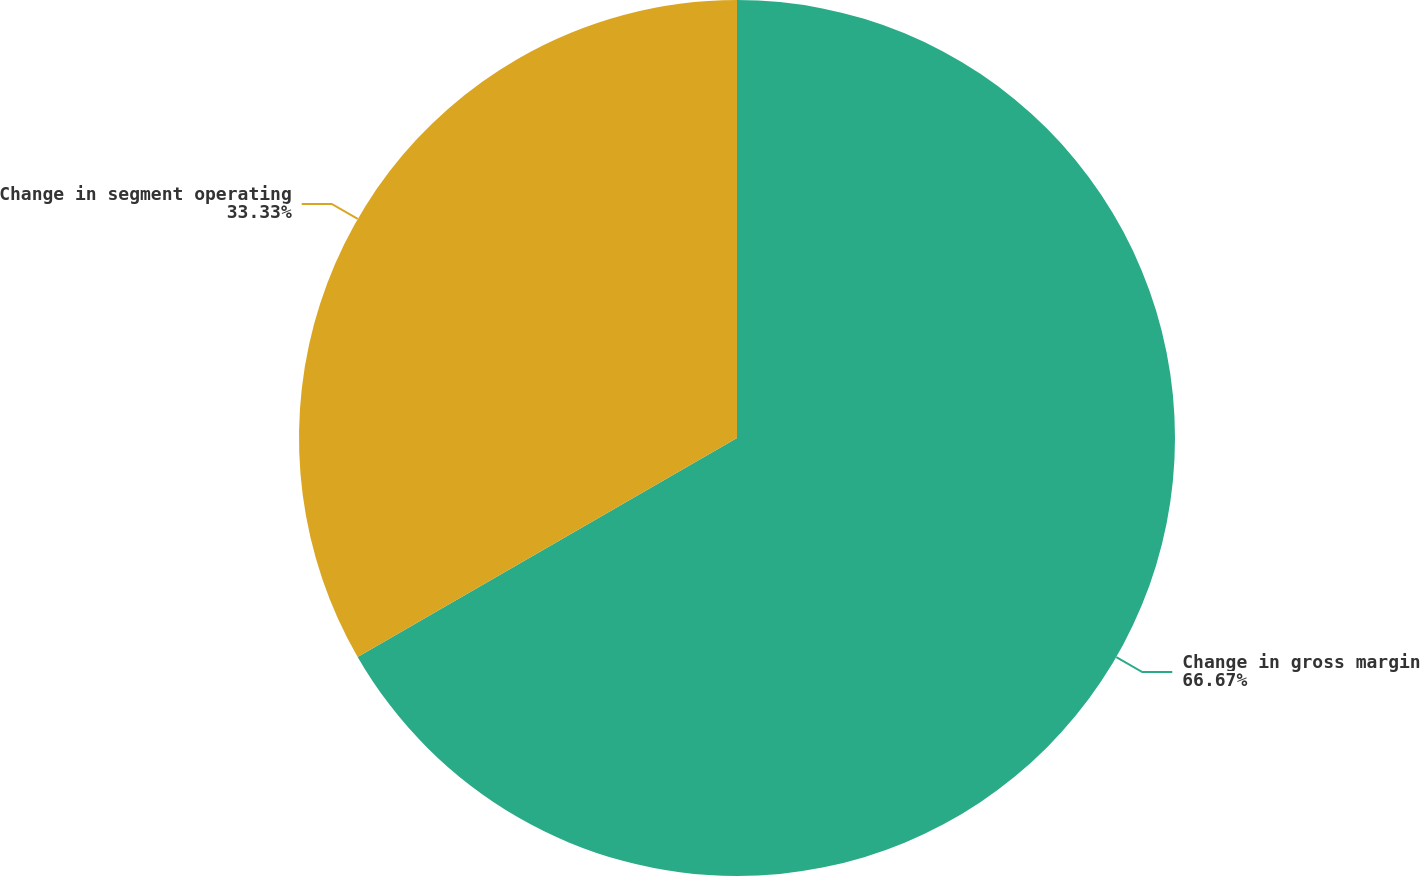Convert chart to OTSL. <chart><loc_0><loc_0><loc_500><loc_500><pie_chart><fcel>Change in gross margin<fcel>Change in segment operating<nl><fcel>66.67%<fcel>33.33%<nl></chart> 